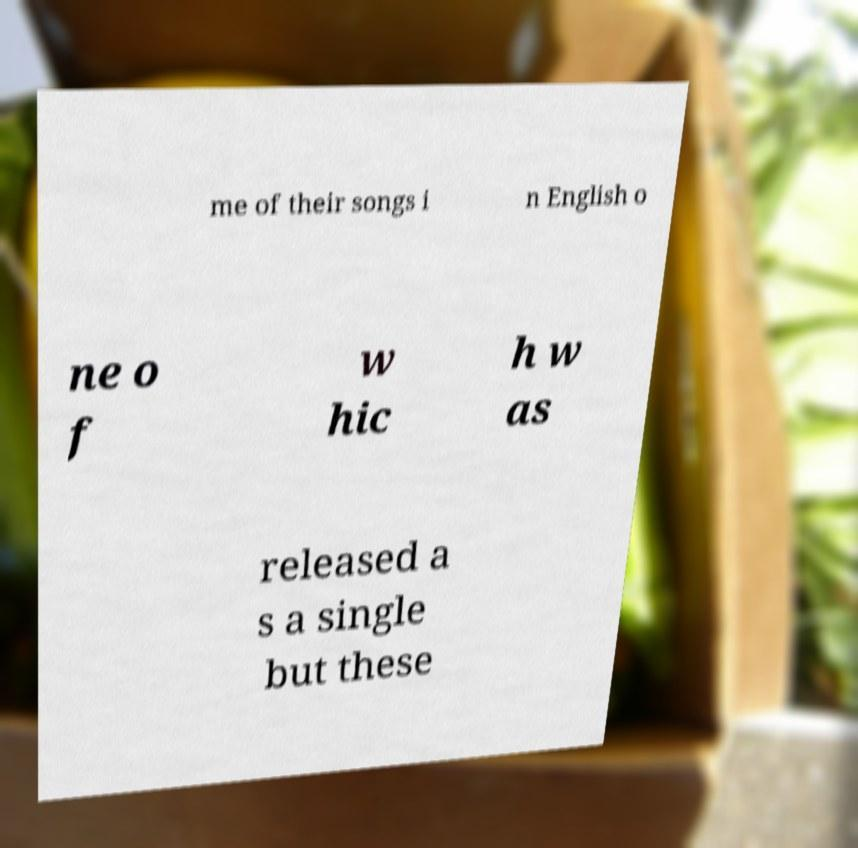Can you read and provide the text displayed in the image?This photo seems to have some interesting text. Can you extract and type it out for me? me of their songs i n English o ne o f w hic h w as released a s a single but these 